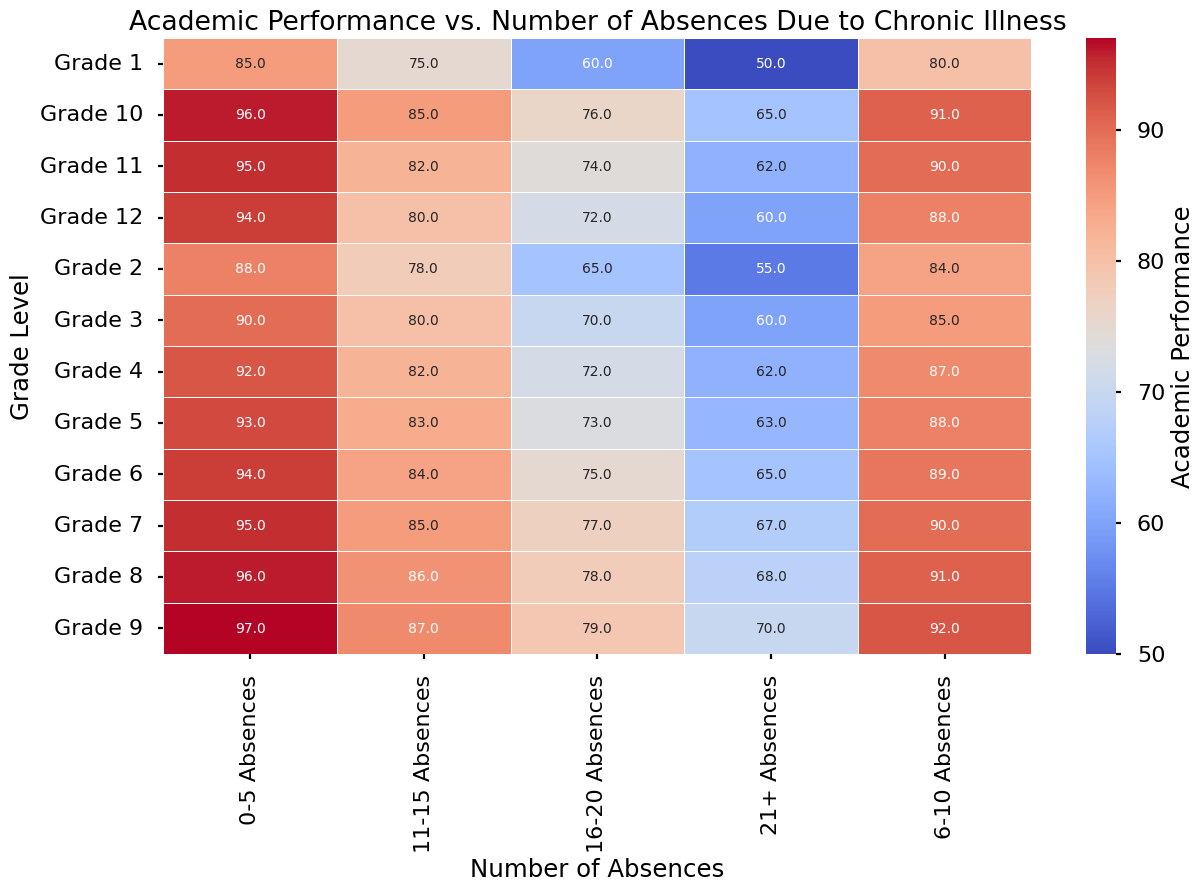What's the general trend of academic performance as the number of absences increases? The chart shows that as the number of absences increases, the academic performance decreases. This downward trend is noticeable across all grade levels, with each additional range of absences corresponding to a lower performance score.
Answer: Academic performance decreases with more absences Between Grade 7 and Grade 8, which has a higher performance with 6-10 absences? To compare the performance between Grade 7 and Grade 8 for 6-10 absences, we find the values in the respective cells: Grade 7 has 90 and Grade 8 has 91. Hence, Grade 8 has a higher performance score.
Answer: Grade 8 How much does the academic performance drop from 0-5 absences to 21+ absences in Grade 5? To find the drop in performance, subtract the performance value for 21+ absences from the corresponding value for 0-5 absences in Grade 5. Therefore, it is 93 - 63 = 30.
Answer: 30 Is there any grade with a performance score of 100 in any absence category? The highest score in each cell, i.e., academic performance, is at most 97 according to the data, so no grade has a performance score of 100.
Answer: No What is the average performance of Grade 4 across all absence categories? Sum the performance scores of Grade 4 across all absence categories and then divide by the number of categories: (92 + 87 + 82 + 72 + 62) / 5 = 79.
Answer: 79 Which grade and absence category combination shows the lowest academic performance? By scanning the heatmap for the lowest value visually, we find that Grade 1 in the 21+ absences category has the lowest performance score of 50.
Answer: Grade 1, 21+ absences How does academic performance in Grade 10 with 21+ absences compare to Grade 12 with the same absences? Locate the performance scores for 21+ absences in both Grade 10 and Grade 12. Grade 10 has 65 whereas Grade 12 has 60. Hence, Grade 10 performs better.
Answer: Grade 10 What is the color trend for Grade 7 across different absence categories? For Grade 7, the color transitions from light (higher scores) to darker shades (lower scores) as absences increase, particularly shifting from lighter shades of blue to shades of red.
Answer: From light blue to red In which absence category does Grade 11 show better performance compared to Grade 12? By comparing each category's performance scores, Grade 11 has better performance (95 vs. 94) at 0-5 absences, (90 vs. 88) at 6-10 absences, (82 vs. 80) at 11-15 absences, and (74 vs. 72) at even 16-20 absences.
Answer: 0-5, 6-10, 11-15, 16-20 